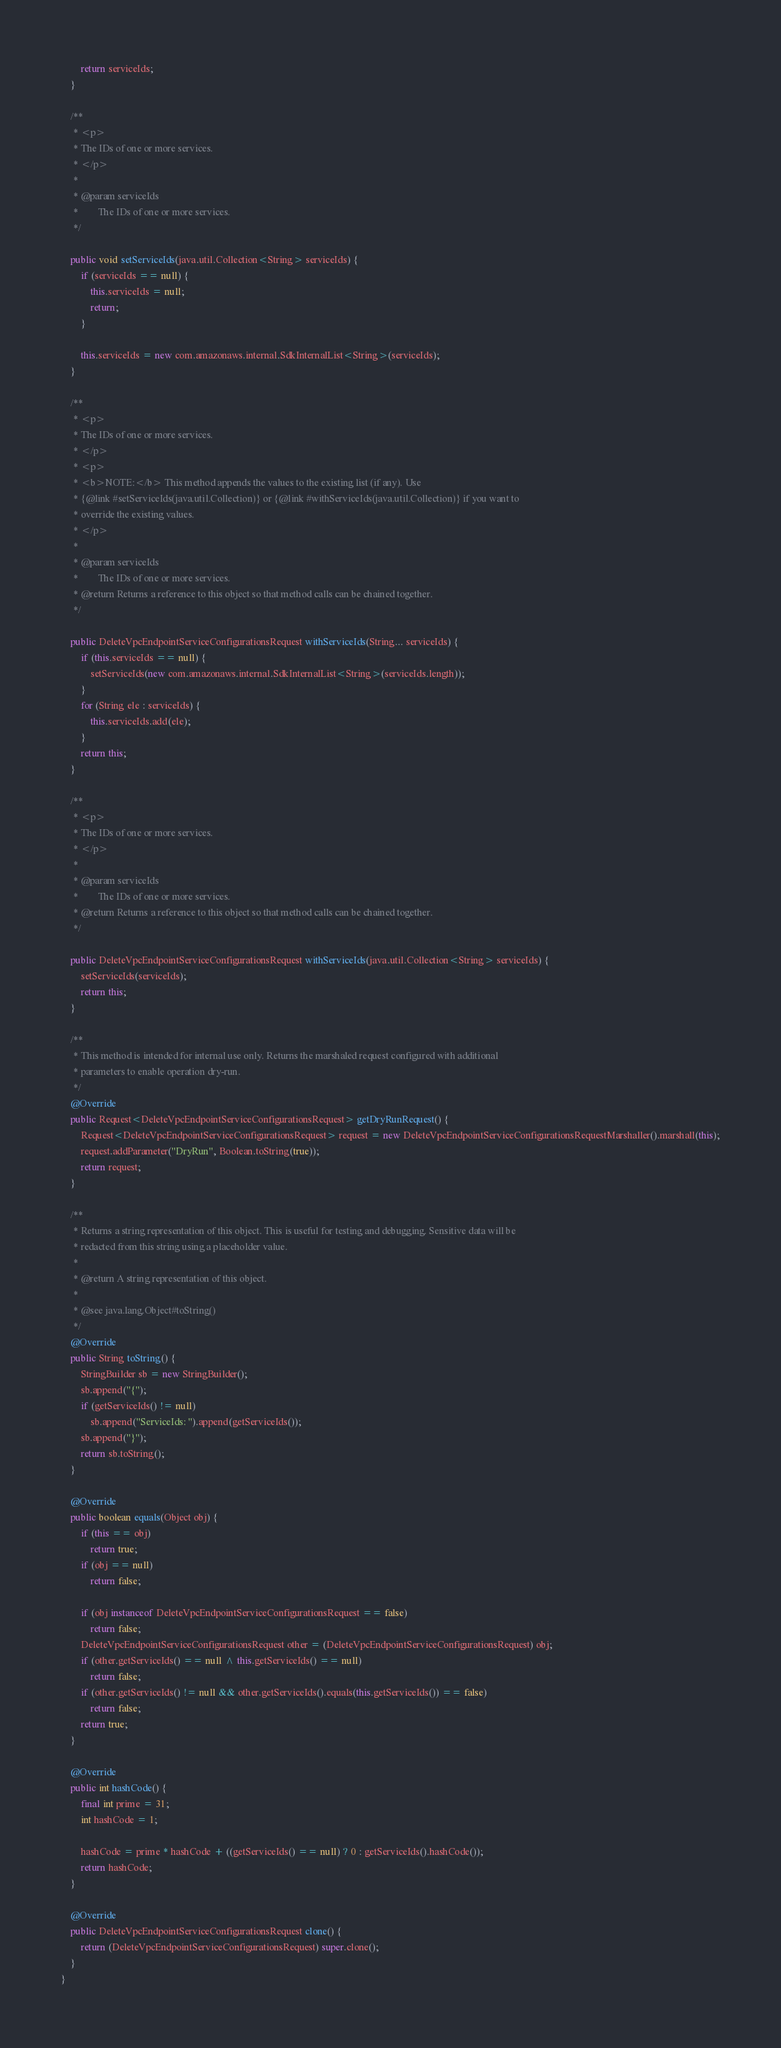Convert code to text. <code><loc_0><loc_0><loc_500><loc_500><_Java_>        return serviceIds;
    }

    /**
     * <p>
     * The IDs of one or more services.
     * </p>
     * 
     * @param serviceIds
     *        The IDs of one or more services.
     */

    public void setServiceIds(java.util.Collection<String> serviceIds) {
        if (serviceIds == null) {
            this.serviceIds = null;
            return;
        }

        this.serviceIds = new com.amazonaws.internal.SdkInternalList<String>(serviceIds);
    }

    /**
     * <p>
     * The IDs of one or more services.
     * </p>
     * <p>
     * <b>NOTE:</b> This method appends the values to the existing list (if any). Use
     * {@link #setServiceIds(java.util.Collection)} or {@link #withServiceIds(java.util.Collection)} if you want to
     * override the existing values.
     * </p>
     * 
     * @param serviceIds
     *        The IDs of one or more services.
     * @return Returns a reference to this object so that method calls can be chained together.
     */

    public DeleteVpcEndpointServiceConfigurationsRequest withServiceIds(String... serviceIds) {
        if (this.serviceIds == null) {
            setServiceIds(new com.amazonaws.internal.SdkInternalList<String>(serviceIds.length));
        }
        for (String ele : serviceIds) {
            this.serviceIds.add(ele);
        }
        return this;
    }

    /**
     * <p>
     * The IDs of one or more services.
     * </p>
     * 
     * @param serviceIds
     *        The IDs of one or more services.
     * @return Returns a reference to this object so that method calls can be chained together.
     */

    public DeleteVpcEndpointServiceConfigurationsRequest withServiceIds(java.util.Collection<String> serviceIds) {
        setServiceIds(serviceIds);
        return this;
    }

    /**
     * This method is intended for internal use only. Returns the marshaled request configured with additional
     * parameters to enable operation dry-run.
     */
    @Override
    public Request<DeleteVpcEndpointServiceConfigurationsRequest> getDryRunRequest() {
        Request<DeleteVpcEndpointServiceConfigurationsRequest> request = new DeleteVpcEndpointServiceConfigurationsRequestMarshaller().marshall(this);
        request.addParameter("DryRun", Boolean.toString(true));
        return request;
    }

    /**
     * Returns a string representation of this object. This is useful for testing and debugging. Sensitive data will be
     * redacted from this string using a placeholder value.
     *
     * @return A string representation of this object.
     *
     * @see java.lang.Object#toString()
     */
    @Override
    public String toString() {
        StringBuilder sb = new StringBuilder();
        sb.append("{");
        if (getServiceIds() != null)
            sb.append("ServiceIds: ").append(getServiceIds());
        sb.append("}");
        return sb.toString();
    }

    @Override
    public boolean equals(Object obj) {
        if (this == obj)
            return true;
        if (obj == null)
            return false;

        if (obj instanceof DeleteVpcEndpointServiceConfigurationsRequest == false)
            return false;
        DeleteVpcEndpointServiceConfigurationsRequest other = (DeleteVpcEndpointServiceConfigurationsRequest) obj;
        if (other.getServiceIds() == null ^ this.getServiceIds() == null)
            return false;
        if (other.getServiceIds() != null && other.getServiceIds().equals(this.getServiceIds()) == false)
            return false;
        return true;
    }

    @Override
    public int hashCode() {
        final int prime = 31;
        int hashCode = 1;

        hashCode = prime * hashCode + ((getServiceIds() == null) ? 0 : getServiceIds().hashCode());
        return hashCode;
    }

    @Override
    public DeleteVpcEndpointServiceConfigurationsRequest clone() {
        return (DeleteVpcEndpointServiceConfigurationsRequest) super.clone();
    }
}
</code> 